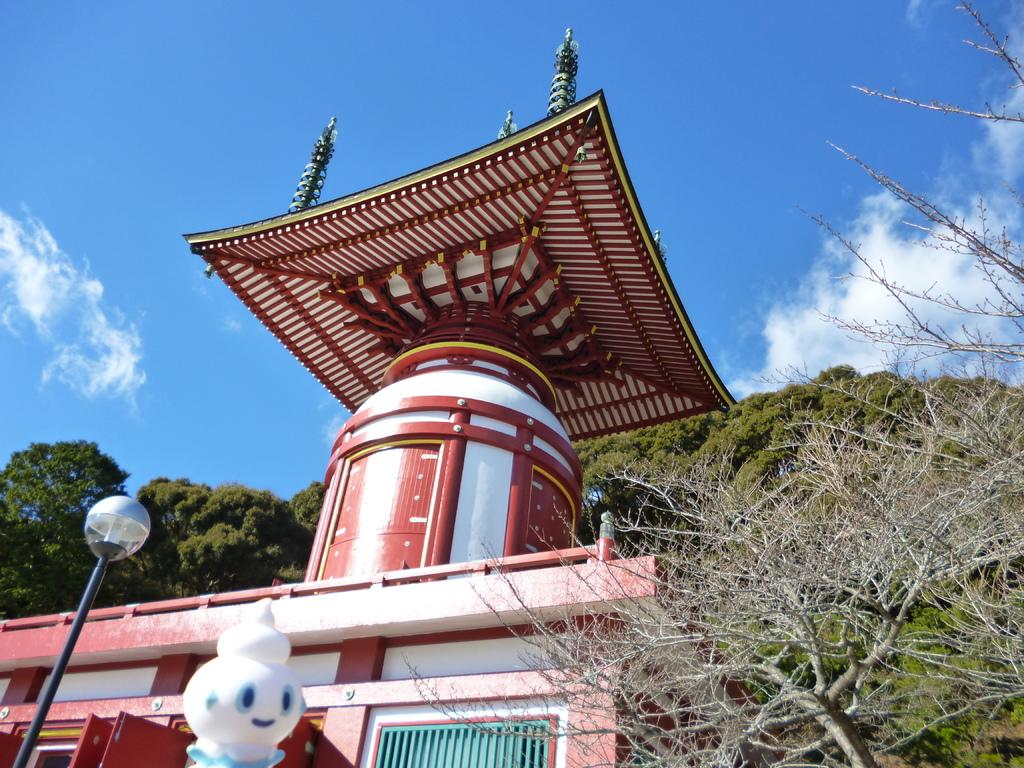What type of structure is visible in the image? There is an architecture in the image. What natural elements can be seen in the image? There are trees in the image. Is there any representation of a character or symbol in the image? Yes, there is a mascot in the image. What type of lighting is present in the image? There is a street light in the image. Are there any openings in the architecture? Yes, there are doors in the image. Can you see any part of the building's interior? Yes, there is a window in the image. What can be seen in the background of the image? The sky and trees are visible in the background of the image. What type of brush is being used by the mascot in the image? There is no brush present in the image, and the mascot is not depicted using any tools or objects. How many sacks are visible in the image? There are no sacks present in the image. 